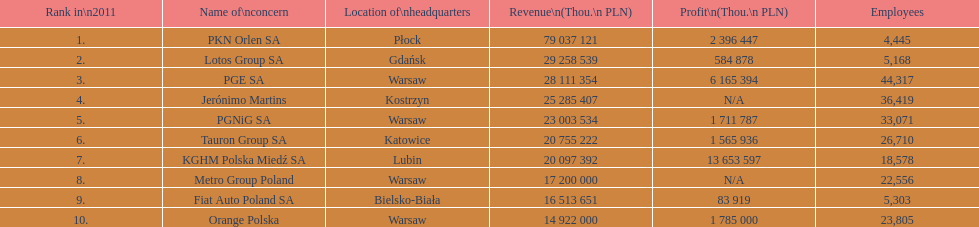At which company can the largest workforce be found? PGE SA. 